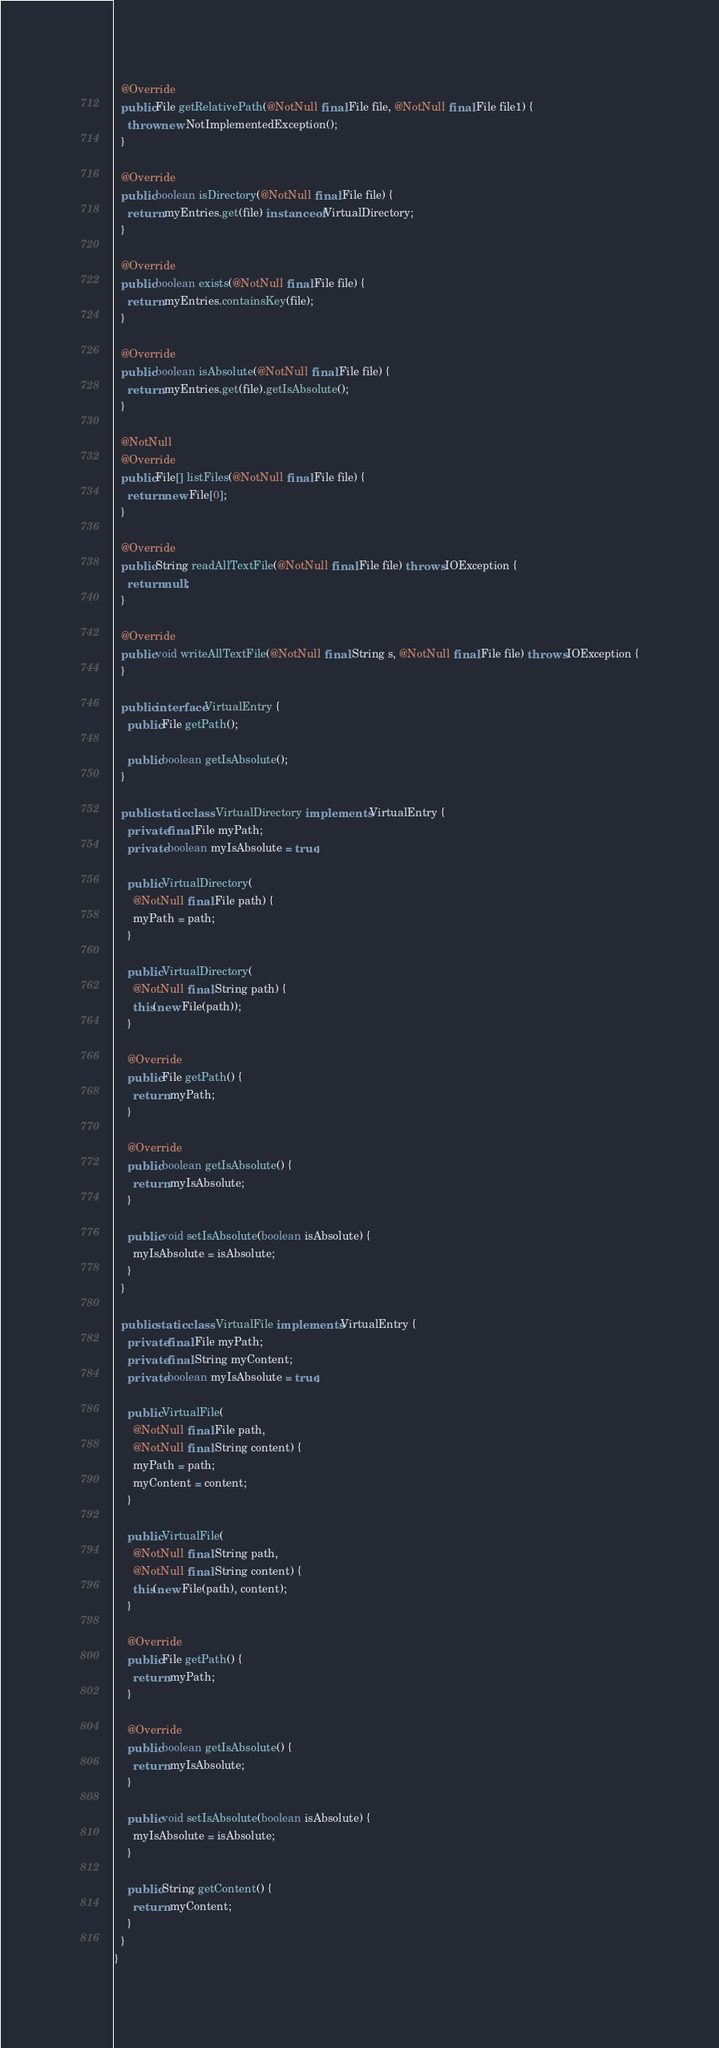Convert code to text. <code><loc_0><loc_0><loc_500><loc_500><_Java_>  @Override
  public File getRelativePath(@NotNull final File file, @NotNull final File file1) {
    throw new NotImplementedException();
  }

  @Override
  public boolean isDirectory(@NotNull final File file) {
    return myEntries.get(file) instanceof VirtualDirectory;
  }

  @Override
  public boolean exists(@NotNull final File file) {
    return myEntries.containsKey(file);
  }

  @Override
  public boolean isAbsolute(@NotNull final File file) {
    return myEntries.get(file).getIsAbsolute();
  }

  @NotNull
  @Override
  public File[] listFiles(@NotNull final File file) {
    return new File[0];
  }

  @Override
  public String readAllTextFile(@NotNull final File file) throws IOException {
    return null;
  }

  @Override
  public void writeAllTextFile(@NotNull final String s, @NotNull final File file) throws IOException {
  }

  public interface VirtualEntry {
    public File getPath();

    public boolean getIsAbsolute();
  }

  public static class VirtualDirectory implements VirtualEntry {
    private final File myPath;
    private boolean myIsAbsolute = true;

    public VirtualDirectory(
      @NotNull final File path) {
      myPath = path;
    }

    public VirtualDirectory(
      @NotNull final String path) {
      this(new File(path));
    }

    @Override
    public File getPath() {
      return myPath;
    }

    @Override
    public boolean getIsAbsolute() {
      return myIsAbsolute;
    }

    public void setIsAbsolute(boolean isAbsolute) {
      myIsAbsolute = isAbsolute;
    }
  }

  public static class VirtualFile implements VirtualEntry {
    private final File myPath;
    private final String myContent;
    private boolean myIsAbsolute = true;

    public VirtualFile(
      @NotNull final File path,
      @NotNull final String content) {
      myPath = path;
      myContent = content;
    }

    public VirtualFile(
      @NotNull final String path,
      @NotNull final String content) {
      this(new File(path), content);
    }

    @Override
    public File getPath() {
      return myPath;
    }

    @Override
    public boolean getIsAbsolute() {
      return myIsAbsolute;
    }

    public void setIsAbsolute(boolean isAbsolute) {
      myIsAbsolute = isAbsolute;
    }

    public String getContent() {
      return myContent;
    }
  }
}
</code> 